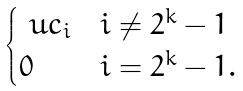Convert formula to latex. <formula><loc_0><loc_0><loc_500><loc_500>\begin{cases} \ u c _ { i } & i \ne 2 ^ { k } - 1 \\ 0 & i = 2 ^ { k } - 1 . \end{cases}</formula> 